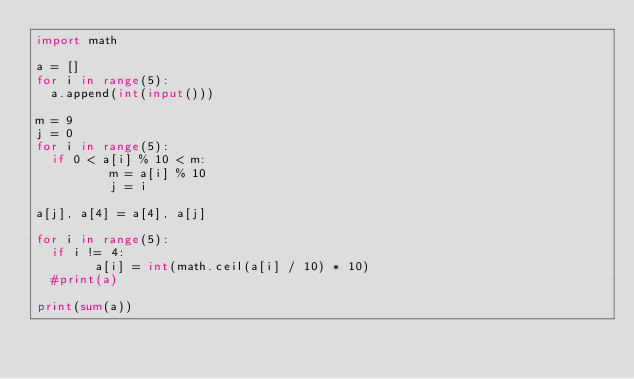Convert code to text. <code><loc_0><loc_0><loc_500><loc_500><_Python_>import math
 
a = []
for i in range(5):
  a.append(int(input()))

m = 9
j = 0
for i in range(5):
  if 0 < a[i] % 10 < m:
          m = a[i] % 10
          j = i

a[j], a[4] = a[4], a[j]

for i in range(5):
  if i != 4:
        a[i] = int(math.ceil(a[i] / 10) * 10)
  #print(a)
  
print(sum(a))</code> 